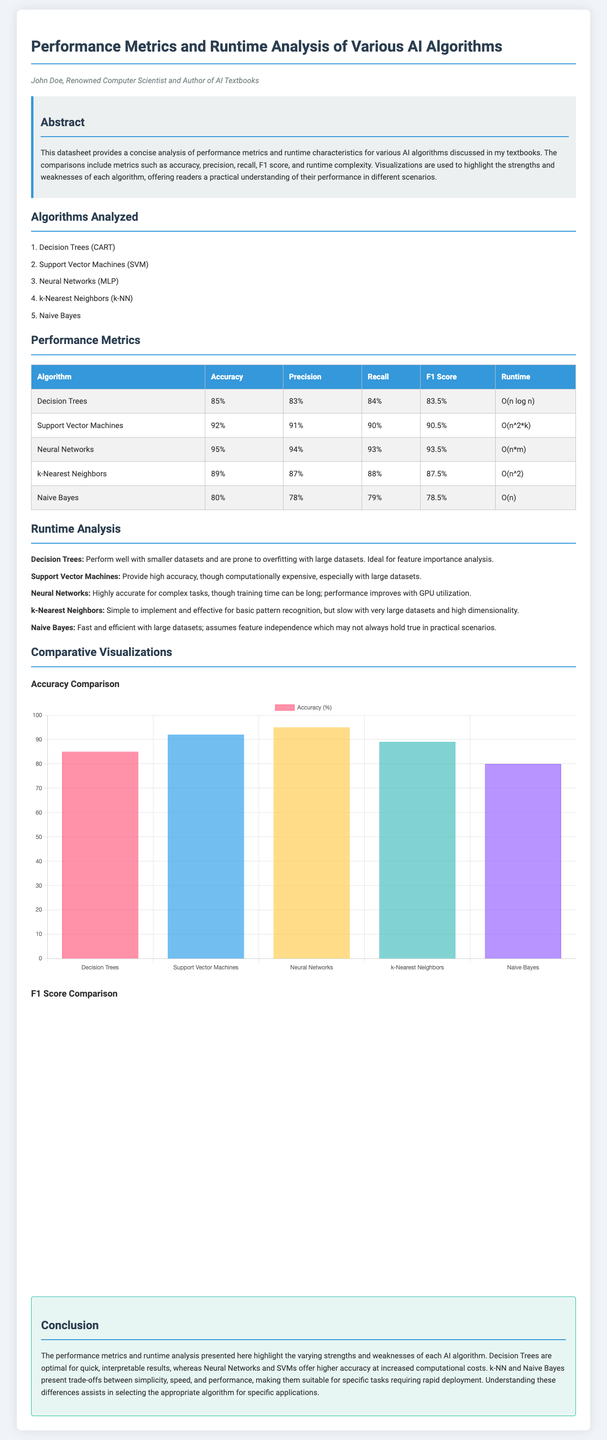What is the accuracy of Neural Networks? The accuracy of Neural Networks is provided in the performance metrics table within the document.
Answer: 95% What is the precision of Support Vector Machines? The precision value for Support Vector Machines can be found in the performance metrics table.
Answer: 91% Which algorithm has the highest F1 score? The F1 score comparisons illustrate which algorithm excels, detailed in the performance metrics table.
Answer: Neural Networks What is the runtime complexity of Naive Bayes? The document specifies the runtime complexities for each algorithm in the performance metrics section.
Answer: O(n) Which algorithm is ideal for feature importance analysis? The runtime analysis section describes high-level observations about each algorithm, including their ideal use cases.
Answer: Decision Trees What is the minimum accuracy among the algorithms analyzed? The document includes accuracy values for each algorithm, allowing for identification of the lowest value.
Answer: 80% Which algorithm is considered computationally expensive? The runtime analysis highlights particular algorithms related to their computational demands.
Answer: Support Vector Machines What type of chart is used for F1 Score comparison? The document describes the format of visual representations for comparing algorithms, specifying the chart types used.
Answer: Horizontal Bar 